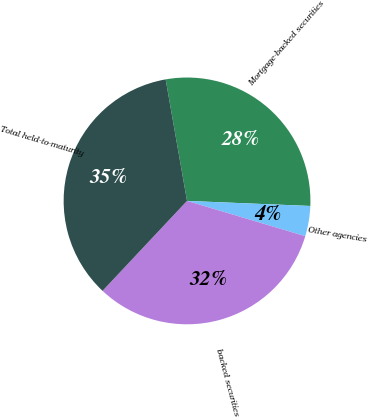<chart> <loc_0><loc_0><loc_500><loc_500><pie_chart><fcel>Mortgage-backed securities<fcel>Other agencies<fcel>backed securities<fcel>Total held-to-maturity<nl><fcel>28.43%<fcel>3.96%<fcel>32.39%<fcel>35.23%<nl></chart> 